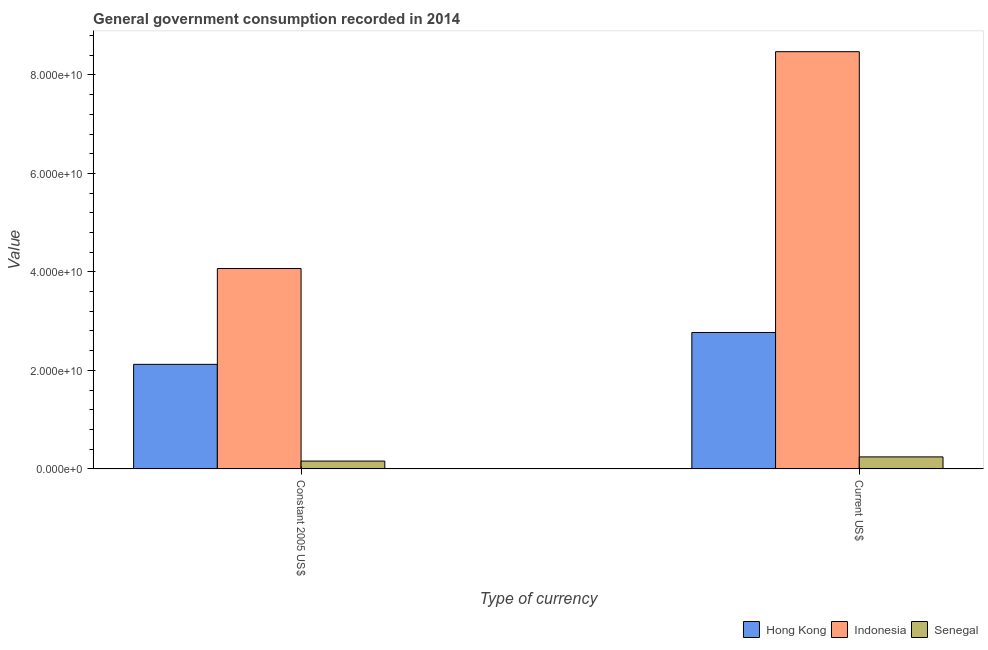How many bars are there on the 1st tick from the right?
Your answer should be compact. 3. What is the label of the 2nd group of bars from the left?
Your answer should be very brief. Current US$. What is the value consumed in current us$ in Hong Kong?
Offer a terse response. 2.77e+1. Across all countries, what is the maximum value consumed in constant 2005 us$?
Give a very brief answer. 4.07e+1. Across all countries, what is the minimum value consumed in constant 2005 us$?
Offer a very short reply. 1.58e+09. In which country was the value consumed in current us$ minimum?
Offer a very short reply. Senegal. What is the total value consumed in constant 2005 us$ in the graph?
Your answer should be compact. 6.35e+1. What is the difference between the value consumed in current us$ in Hong Kong and that in Indonesia?
Ensure brevity in your answer.  -5.70e+1. What is the difference between the value consumed in constant 2005 us$ in Indonesia and the value consumed in current us$ in Hong Kong?
Your response must be concise. 1.30e+1. What is the average value consumed in constant 2005 us$ per country?
Make the answer very short. 2.12e+1. What is the difference between the value consumed in current us$ and value consumed in constant 2005 us$ in Hong Kong?
Give a very brief answer. 6.47e+09. In how many countries, is the value consumed in current us$ greater than 76000000000 ?
Provide a short and direct response. 1. What is the ratio of the value consumed in current us$ in Indonesia to that in Senegal?
Your response must be concise. 34.9. In how many countries, is the value consumed in current us$ greater than the average value consumed in current us$ taken over all countries?
Make the answer very short. 1. What does the 3rd bar from the left in Constant 2005 US$ represents?
Offer a very short reply. Senegal. What does the 3rd bar from the right in Constant 2005 US$ represents?
Keep it short and to the point. Hong Kong. Are all the bars in the graph horizontal?
Your answer should be compact. No. How many countries are there in the graph?
Give a very brief answer. 3. What is the title of the graph?
Offer a very short reply. General government consumption recorded in 2014. What is the label or title of the X-axis?
Ensure brevity in your answer.  Type of currency. What is the label or title of the Y-axis?
Ensure brevity in your answer.  Value. What is the Value in Hong Kong in Constant 2005 US$?
Your response must be concise. 2.12e+1. What is the Value of Indonesia in Constant 2005 US$?
Offer a very short reply. 4.07e+1. What is the Value of Senegal in Constant 2005 US$?
Ensure brevity in your answer.  1.58e+09. What is the Value in Hong Kong in Current US$?
Your answer should be very brief. 2.77e+1. What is the Value of Indonesia in Current US$?
Provide a succinct answer. 8.47e+1. What is the Value of Senegal in Current US$?
Give a very brief answer. 2.43e+09. Across all Type of currency, what is the maximum Value in Hong Kong?
Provide a short and direct response. 2.77e+1. Across all Type of currency, what is the maximum Value in Indonesia?
Your answer should be very brief. 8.47e+1. Across all Type of currency, what is the maximum Value in Senegal?
Offer a very short reply. 2.43e+09. Across all Type of currency, what is the minimum Value of Hong Kong?
Provide a succinct answer. 2.12e+1. Across all Type of currency, what is the minimum Value in Indonesia?
Your answer should be compact. 4.07e+1. Across all Type of currency, what is the minimum Value of Senegal?
Provide a succinct answer. 1.58e+09. What is the total Value of Hong Kong in the graph?
Make the answer very short. 4.89e+1. What is the total Value in Indonesia in the graph?
Make the answer very short. 1.25e+11. What is the total Value of Senegal in the graph?
Give a very brief answer. 4.01e+09. What is the difference between the Value in Hong Kong in Constant 2005 US$ and that in Current US$?
Provide a short and direct response. -6.47e+09. What is the difference between the Value of Indonesia in Constant 2005 US$ and that in Current US$?
Your response must be concise. -4.40e+1. What is the difference between the Value of Senegal in Constant 2005 US$ and that in Current US$?
Ensure brevity in your answer.  -8.48e+08. What is the difference between the Value in Hong Kong in Constant 2005 US$ and the Value in Indonesia in Current US$?
Give a very brief answer. -6.35e+1. What is the difference between the Value in Hong Kong in Constant 2005 US$ and the Value in Senegal in Current US$?
Keep it short and to the point. 1.88e+1. What is the difference between the Value of Indonesia in Constant 2005 US$ and the Value of Senegal in Current US$?
Your answer should be very brief. 3.83e+1. What is the average Value in Hong Kong per Type of currency?
Offer a very short reply. 2.45e+1. What is the average Value of Indonesia per Type of currency?
Give a very brief answer. 6.27e+1. What is the average Value in Senegal per Type of currency?
Give a very brief answer. 2.00e+09. What is the difference between the Value in Hong Kong and Value in Indonesia in Constant 2005 US$?
Offer a terse response. -1.95e+1. What is the difference between the Value of Hong Kong and Value of Senegal in Constant 2005 US$?
Keep it short and to the point. 1.96e+1. What is the difference between the Value of Indonesia and Value of Senegal in Constant 2005 US$?
Provide a succinct answer. 3.91e+1. What is the difference between the Value of Hong Kong and Value of Indonesia in Current US$?
Your answer should be very brief. -5.70e+1. What is the difference between the Value of Hong Kong and Value of Senegal in Current US$?
Provide a succinct answer. 2.53e+1. What is the difference between the Value of Indonesia and Value of Senegal in Current US$?
Provide a succinct answer. 8.23e+1. What is the ratio of the Value in Hong Kong in Constant 2005 US$ to that in Current US$?
Keep it short and to the point. 0.77. What is the ratio of the Value of Indonesia in Constant 2005 US$ to that in Current US$?
Your answer should be compact. 0.48. What is the ratio of the Value of Senegal in Constant 2005 US$ to that in Current US$?
Ensure brevity in your answer.  0.65. What is the difference between the highest and the second highest Value of Hong Kong?
Your response must be concise. 6.47e+09. What is the difference between the highest and the second highest Value of Indonesia?
Provide a short and direct response. 4.40e+1. What is the difference between the highest and the second highest Value of Senegal?
Give a very brief answer. 8.48e+08. What is the difference between the highest and the lowest Value of Hong Kong?
Provide a short and direct response. 6.47e+09. What is the difference between the highest and the lowest Value of Indonesia?
Your answer should be compact. 4.40e+1. What is the difference between the highest and the lowest Value in Senegal?
Ensure brevity in your answer.  8.48e+08. 